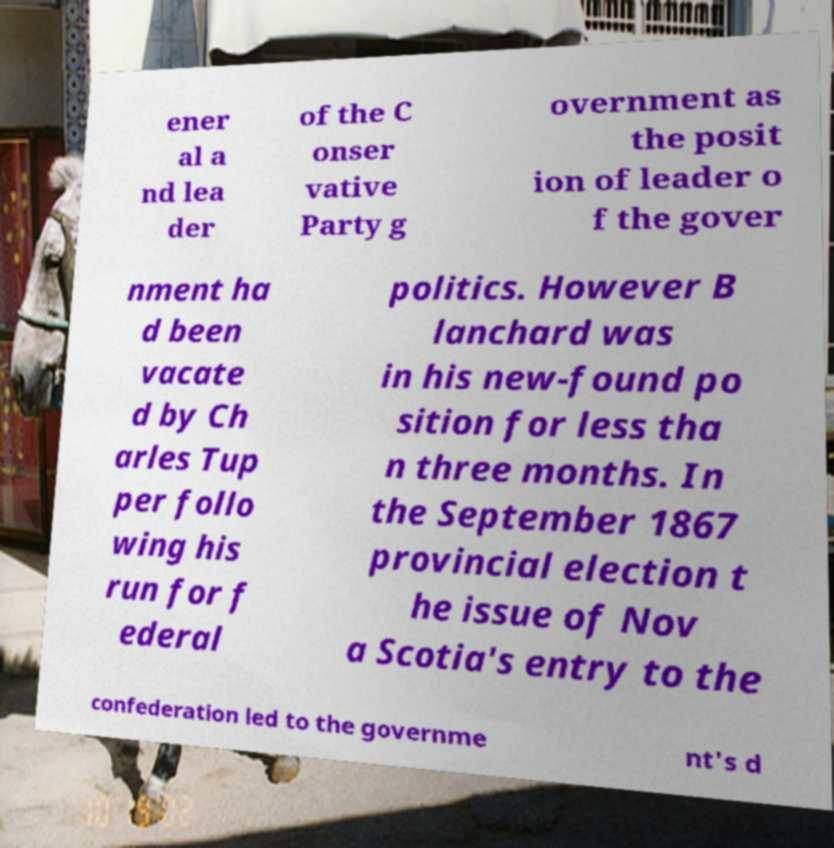Please read and relay the text visible in this image. What does it say? ener al a nd lea der of the C onser vative Party g overnment as the posit ion of leader o f the gover nment ha d been vacate d by Ch arles Tup per follo wing his run for f ederal politics. However B lanchard was in his new-found po sition for less tha n three months. In the September 1867 provincial election t he issue of Nov a Scotia's entry to the confederation led to the governme nt's d 